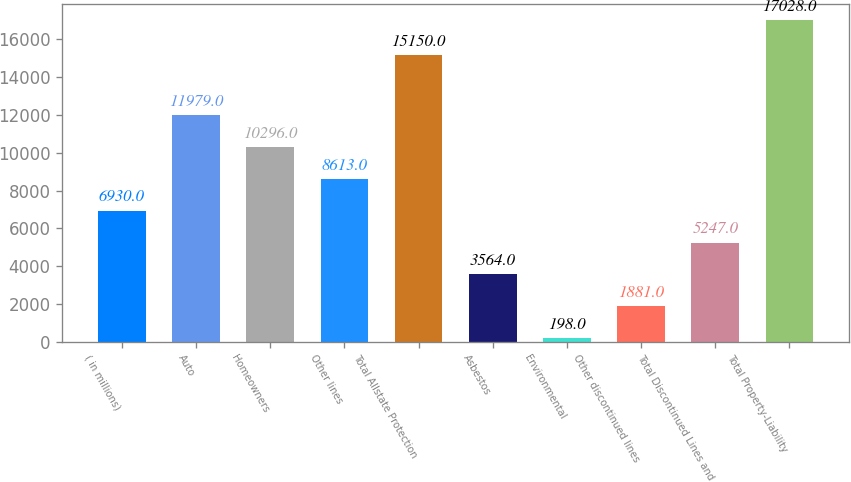Convert chart to OTSL. <chart><loc_0><loc_0><loc_500><loc_500><bar_chart><fcel>( in millions)<fcel>Auto<fcel>Homeowners<fcel>Other lines<fcel>Total Allstate Protection<fcel>Asbestos<fcel>Environmental<fcel>Other discontinued lines<fcel>Total Discontinued Lines and<fcel>Total Property-Liability<nl><fcel>6930<fcel>11979<fcel>10296<fcel>8613<fcel>15150<fcel>3564<fcel>198<fcel>1881<fcel>5247<fcel>17028<nl></chart> 